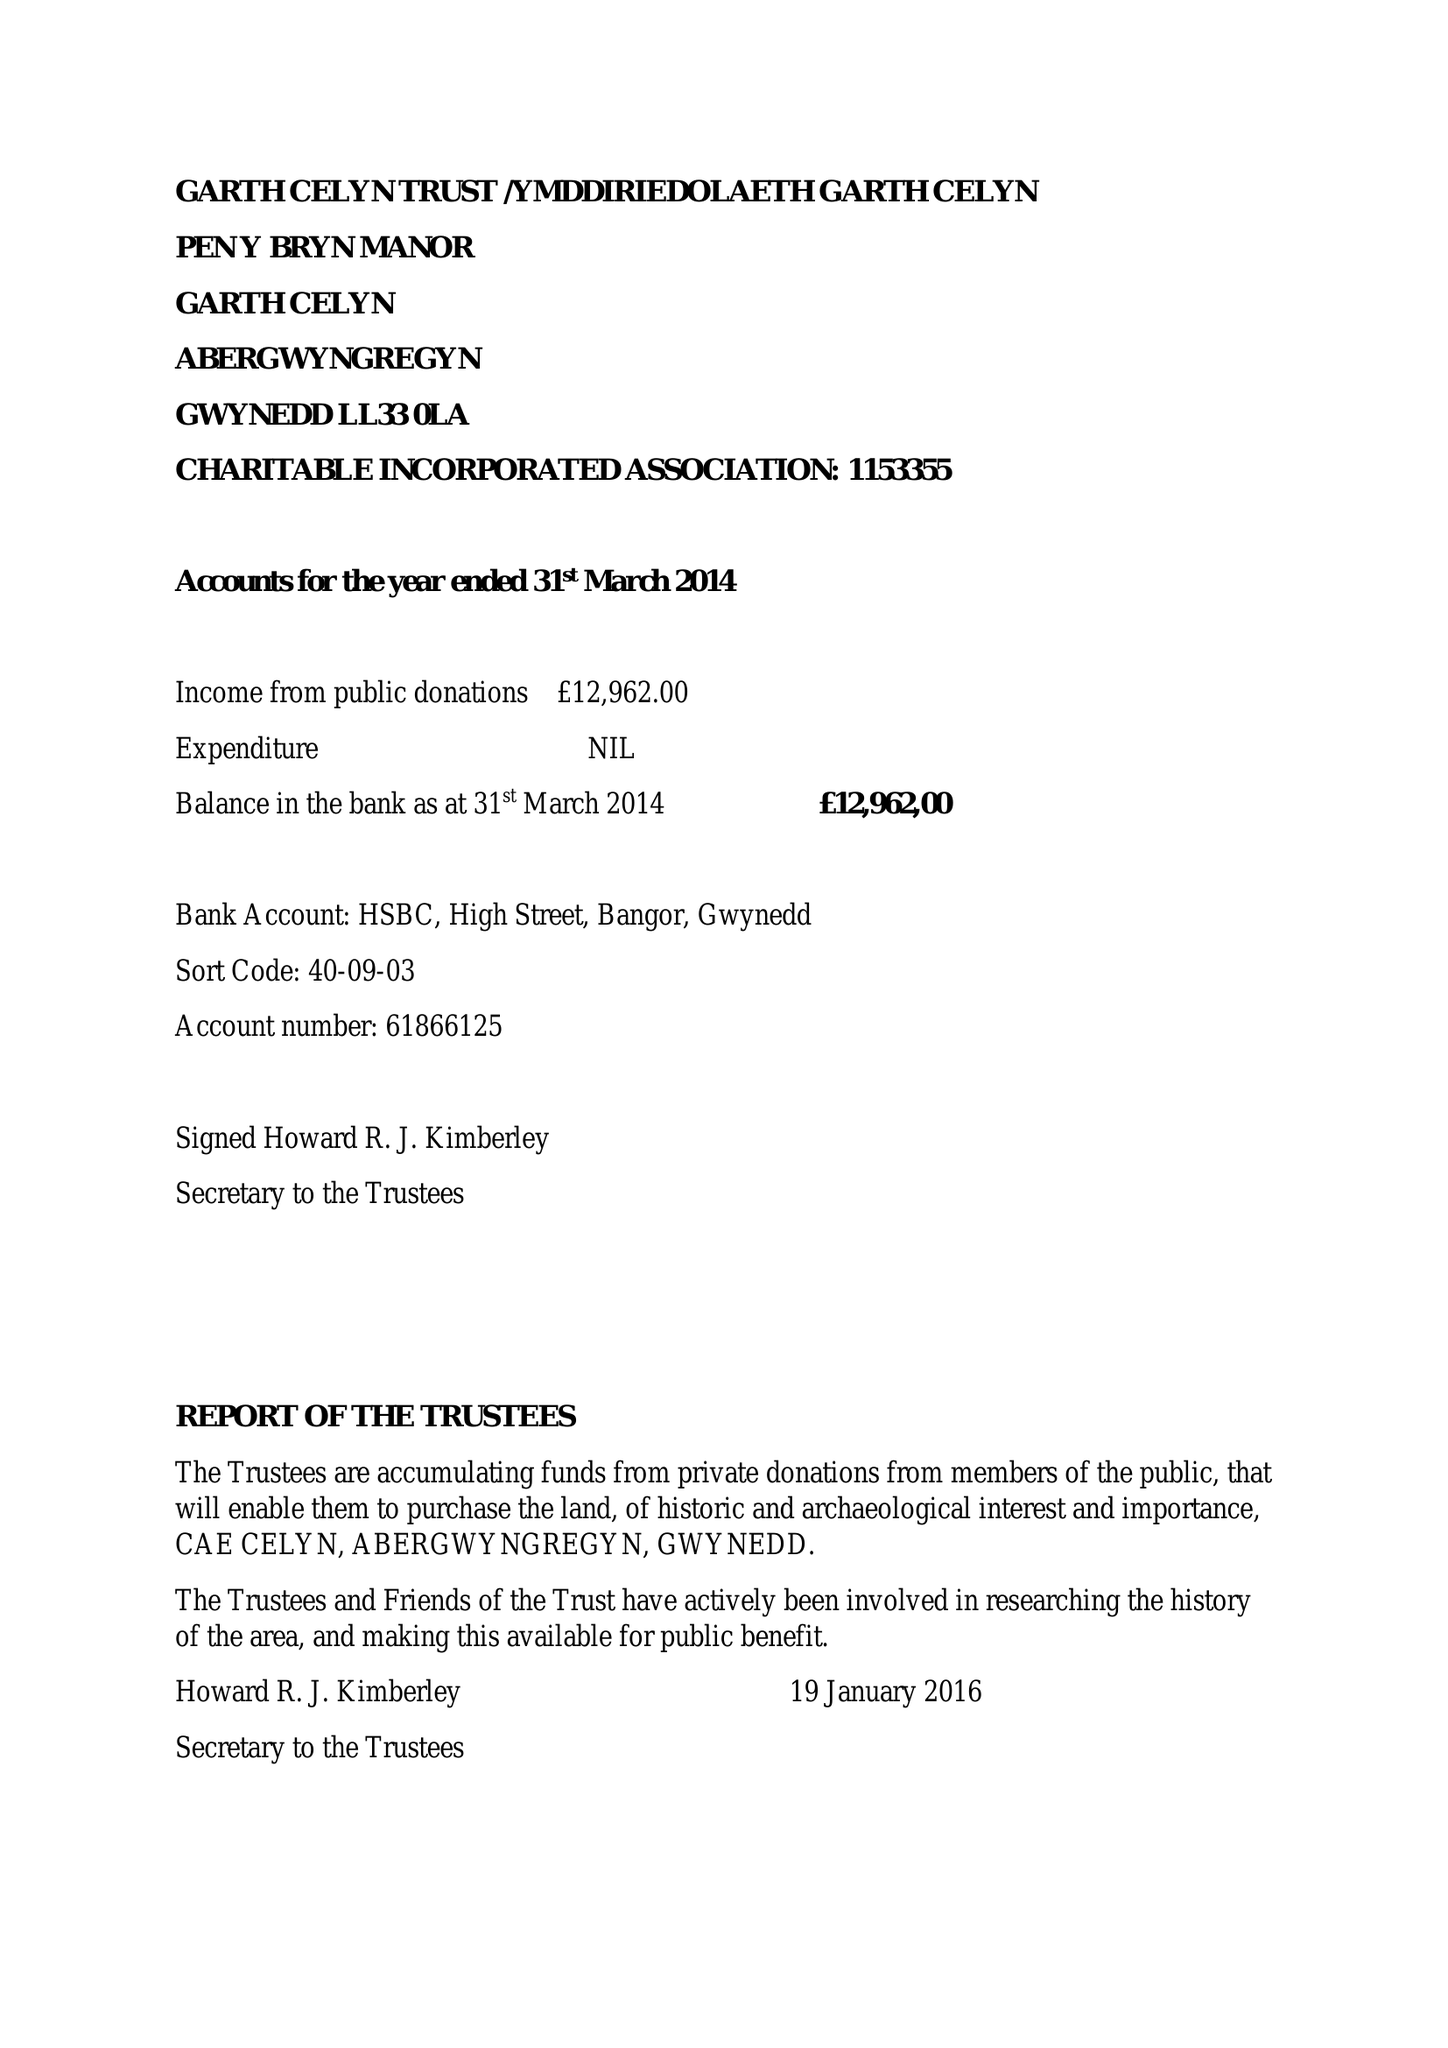What is the value for the income_annually_in_british_pounds?
Answer the question using a single word or phrase. 17633.00 